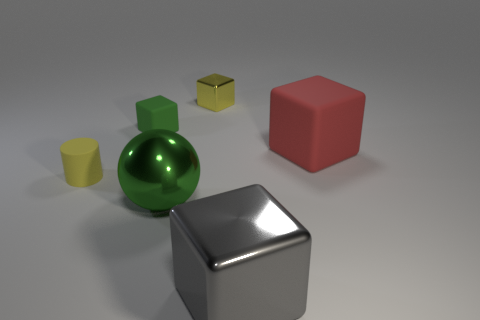Do the metallic object that is on the left side of the tiny metallic thing and the small object in front of the green matte thing have the same shape?
Ensure brevity in your answer.  No. Are there any brown spheres that have the same material as the big red thing?
Give a very brief answer. No. How many blue things are either cylinders or small rubber cubes?
Your response must be concise. 0. There is a rubber object that is both behind the cylinder and to the left of the large red matte cube; what is its size?
Your response must be concise. Small. Are there more objects that are on the left side of the large metal ball than large red rubber things?
Make the answer very short. Yes. What number of cubes are big rubber objects or gray shiny things?
Your answer should be very brief. 2. There is a rubber object that is to the left of the large red matte thing and behind the matte cylinder; what is its shape?
Offer a very short reply. Cube. Is the number of large gray blocks behind the green matte object the same as the number of green blocks to the right of the big red thing?
Your answer should be compact. Yes. How many things are either tiny brown shiny things or tiny yellow cylinders?
Keep it short and to the point. 1. There is a metallic cube that is the same size as the green rubber block; what color is it?
Your answer should be very brief. Yellow. 